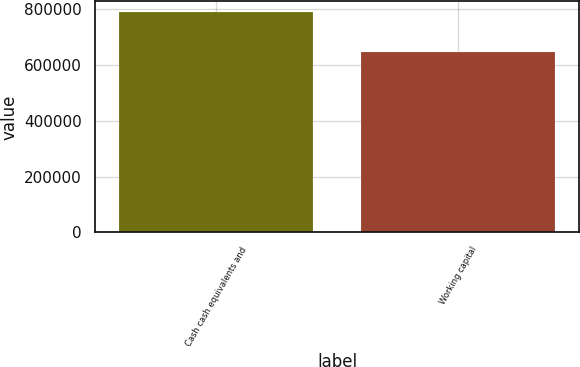<chart> <loc_0><loc_0><loc_500><loc_500><bar_chart><fcel>Cash cash equivalents and<fcel>Working capital<nl><fcel>788778<fcel>645394<nl></chart> 